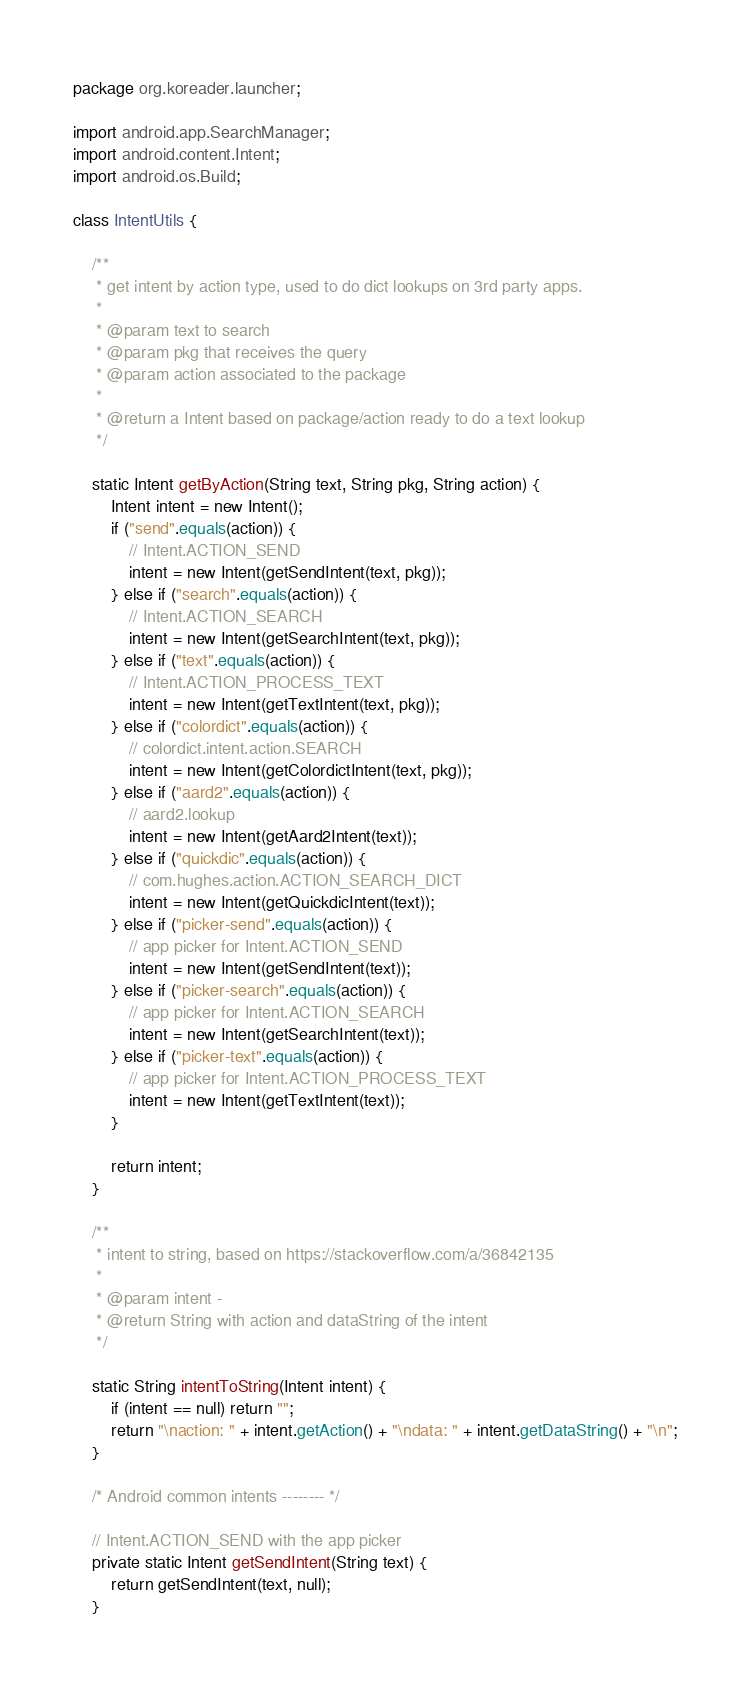Convert code to text. <code><loc_0><loc_0><loc_500><loc_500><_Java_>package org.koreader.launcher;

import android.app.SearchManager;
import android.content.Intent;
import android.os.Build;

class IntentUtils {

    /**
     * get intent by action type, used to do dict lookups on 3rd party apps.
     *
     * @param text to search
     * @param pkg that receives the query
     * @param action associated to the package
     *
     * @return a Intent based on package/action ready to do a text lookup
     */

    static Intent getByAction(String text, String pkg, String action) {
        Intent intent = new Intent();
        if ("send".equals(action)) {
            // Intent.ACTION_SEND
            intent = new Intent(getSendIntent(text, pkg));
        } else if ("search".equals(action)) {
            // Intent.ACTION_SEARCH
            intent = new Intent(getSearchIntent(text, pkg));
        } else if ("text".equals(action)) {
            // Intent.ACTION_PROCESS_TEXT
            intent = new Intent(getTextIntent(text, pkg));
        } else if ("colordict".equals(action)) {
            // colordict.intent.action.SEARCH
            intent = new Intent(getColordictIntent(text, pkg));
        } else if ("aard2".equals(action)) {
            // aard2.lookup
            intent = new Intent(getAard2Intent(text));
        } else if ("quickdic".equals(action)) {
            // com.hughes.action.ACTION_SEARCH_DICT
            intent = new Intent(getQuickdicIntent(text));
        } else if ("picker-send".equals(action)) {
            // app picker for Intent.ACTION_SEND
            intent = new Intent(getSendIntent(text));
        } else if ("picker-search".equals(action)) {
            // app picker for Intent.ACTION_SEARCH
            intent = new Intent(getSearchIntent(text));
        } else if ("picker-text".equals(action)) {
            // app picker for Intent.ACTION_PROCESS_TEXT
            intent = new Intent(getTextIntent(text));
        }

        return intent;
    }

    /**
     * intent to string, based on https://stackoverflow.com/a/36842135
     *
     * @param intent -
     * @return String with action and dataString of the intent
     */

    static String intentToString(Intent intent) {
        if (intent == null) return "";
        return "\naction: " + intent.getAction() + "\ndata: " + intent.getDataString() + "\n";
    }

    /* Android common intents -------- */

    // Intent.ACTION_SEND with the app picker
    private static Intent getSendIntent(String text) {
        return getSendIntent(text, null);
    }
</code> 